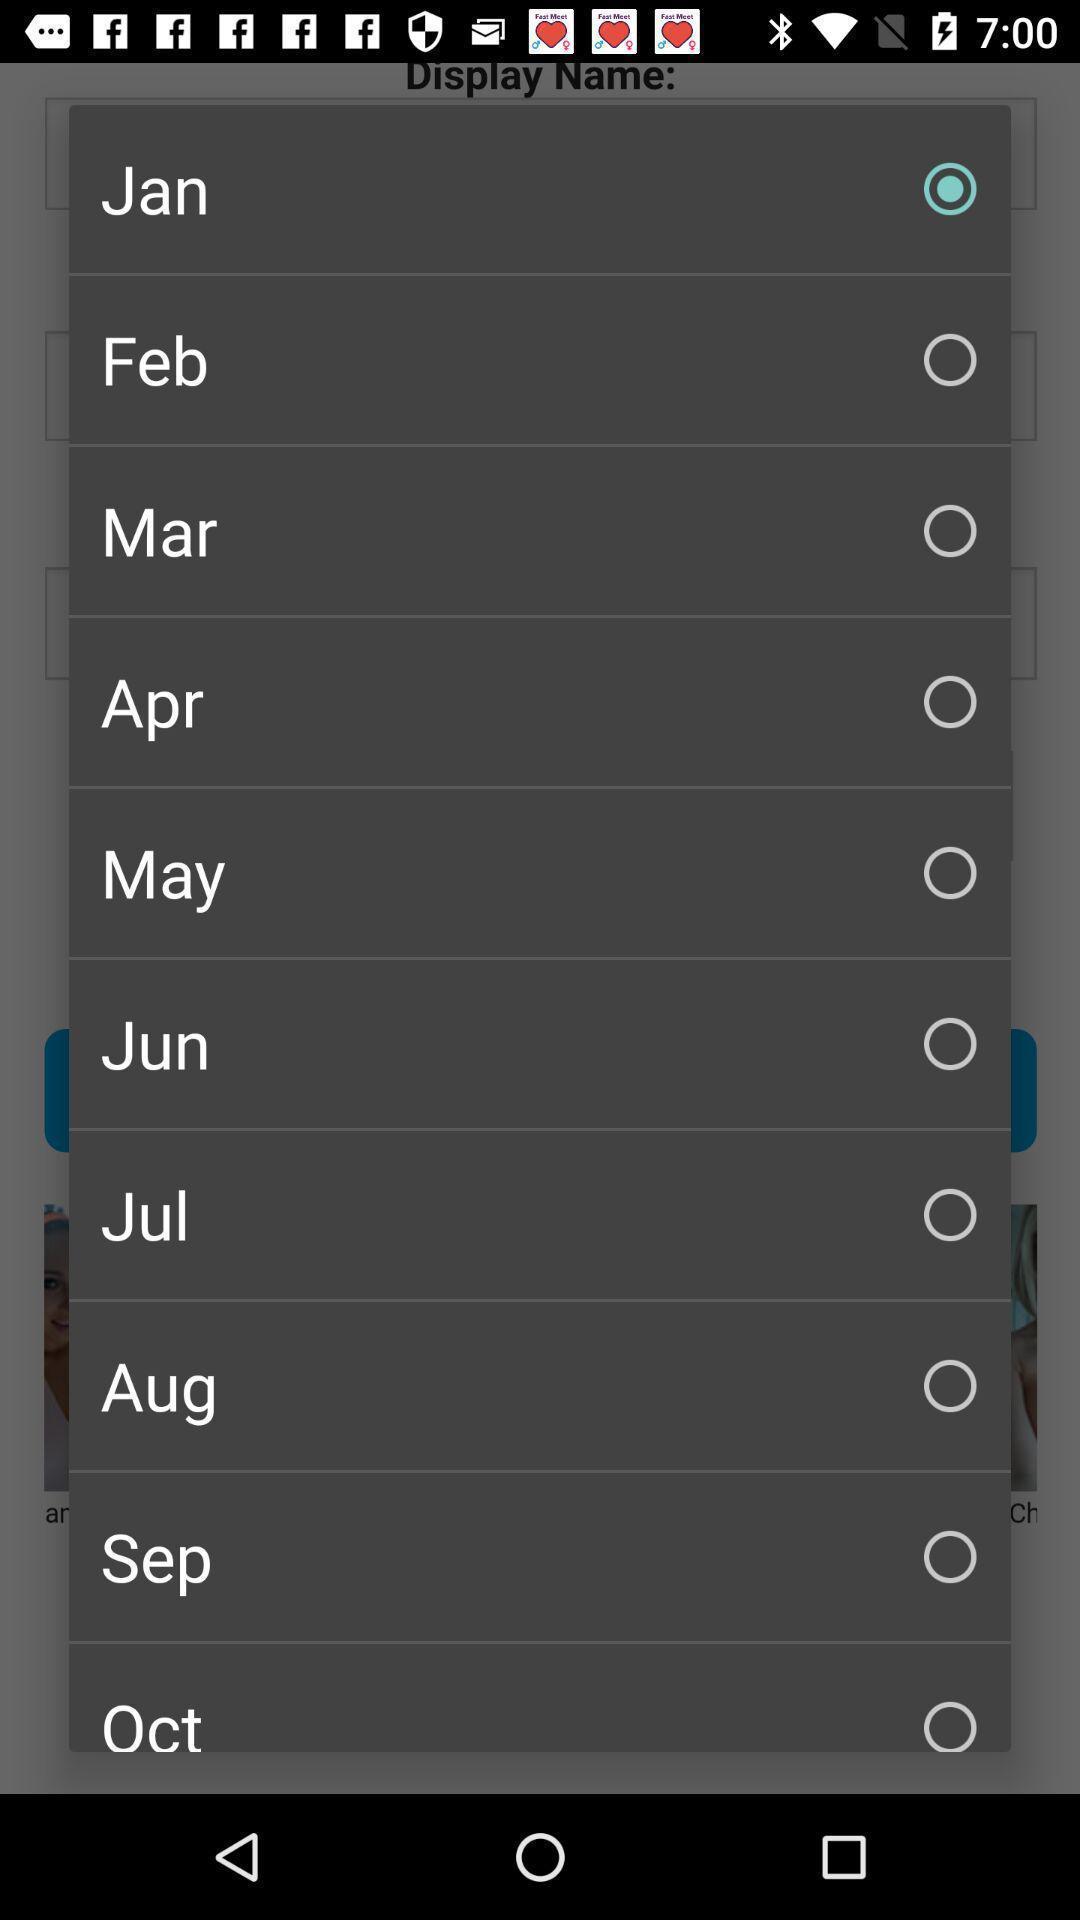What details can you identify in this image? Pop up showing list of months to select. 